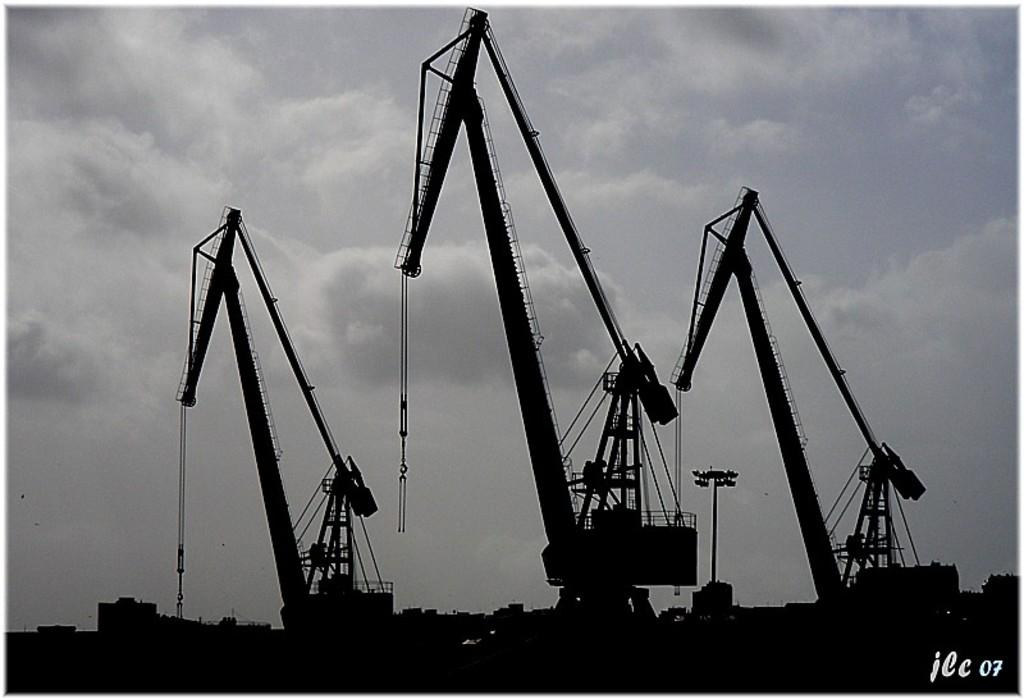What type of construction equipment can be seen in the image? There are tower cranes in the image. What type of lighting is present in the image? There is a flood light in the image. What can be seen in the sky in the image? There are clouds in the sky in the image. Is there any text or logo visible in the image? Yes, there is a watermark in the bottom right corner of the image. What type of skin care product is being advertised in the image? There is no skin care product or advertisement present in the image. What type of songs can be heard in the background of the image? There is no audio or music present in the image. 